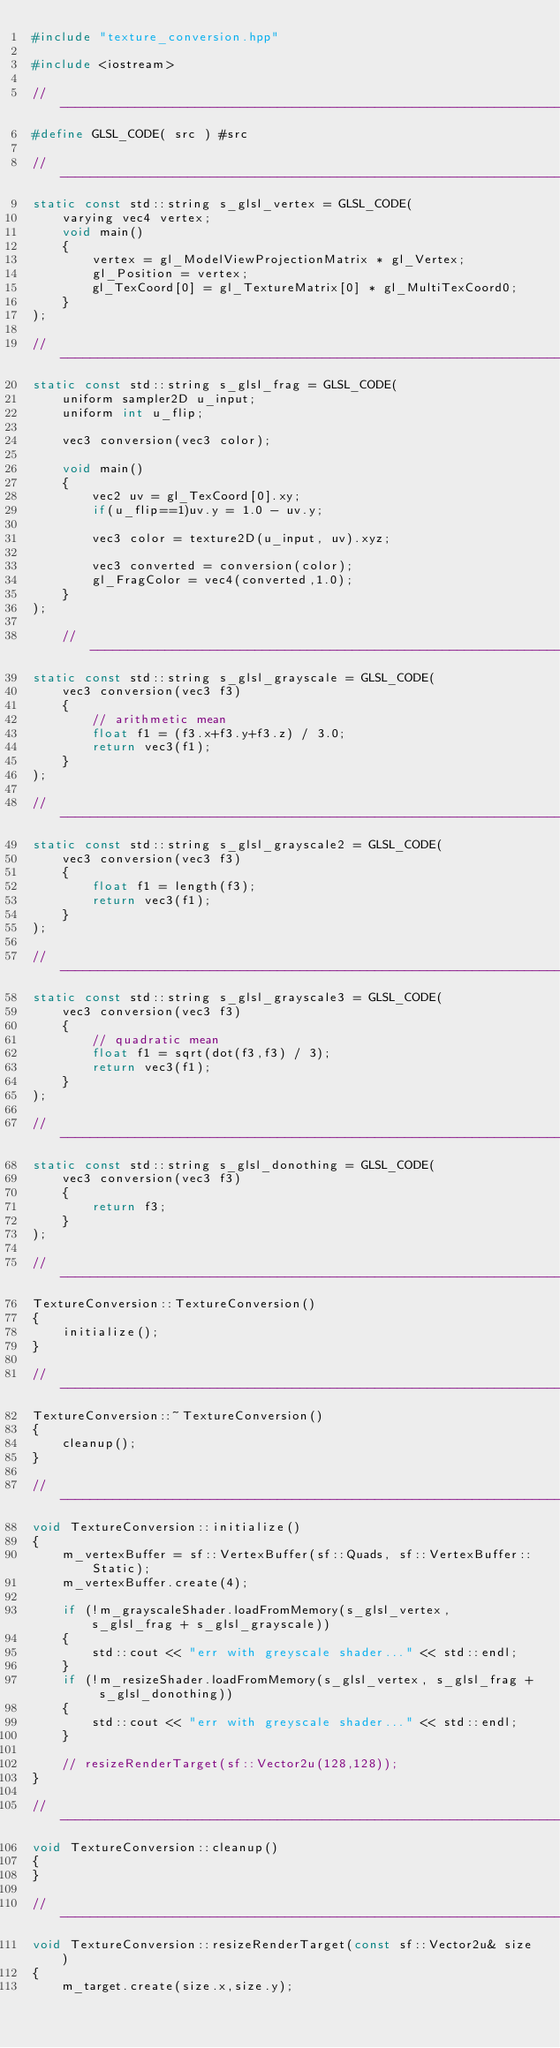Convert code to text. <code><loc_0><loc_0><loc_500><loc_500><_C++_>#include "texture_conversion.hpp"

#include <iostream>

// --------------------------------------------------------------------------
#define GLSL_CODE( src ) #src

// --------------------------------------------------------------------------
static const std::string s_glsl_vertex = GLSL_CODE(
    varying vec4 vertex;
    void main()
    {
        vertex = gl_ModelViewProjectionMatrix * gl_Vertex;
        gl_Position = vertex;
        gl_TexCoord[0] = gl_TextureMatrix[0] * gl_MultiTexCoord0;
    }
);

// --------------------------------------------------------------------------
static const std::string s_glsl_frag = GLSL_CODE(
    uniform sampler2D u_input;
    uniform int u_flip;

    vec3 conversion(vec3 color);

    void main()
    {
        vec2 uv = gl_TexCoord[0].xy;
        if(u_flip==1)uv.y = 1.0 - uv.y;

        vec3 color = texture2D(u_input, uv).xyz;

        vec3 converted = conversion(color);
        gl_FragColor = vec4(converted,1.0);
    }
);

    // --------------------------------------------------------------------------
static const std::string s_glsl_grayscale = GLSL_CODE(
    vec3 conversion(vec3 f3)
    {
        // arithmetic mean
        float f1 = (f3.x+f3.y+f3.z) / 3.0;
        return vec3(f1);
    }
);

// --------------------------------------------------------------------------
static const std::string s_glsl_grayscale2 = GLSL_CODE(
    vec3 conversion(vec3 f3)
    {
        float f1 = length(f3);
        return vec3(f1);
    }
);

// --------------------------------------------------------------------------
static const std::string s_glsl_grayscale3 = GLSL_CODE(
    vec3 conversion(vec3 f3)
    {
        // quadratic mean
        float f1 = sqrt(dot(f3,f3) / 3);
        return vec3(f1);
    }
);

// --------------------------------------------------------------------------
static const std::string s_glsl_donothing = GLSL_CODE(
    vec3 conversion(vec3 f3)
    {
        return f3;
    }
);

// --------------------------------------------------------------------------
TextureConversion::TextureConversion()
{
    initialize();
}

// --------------------------------------------------------------------------
TextureConversion::~TextureConversion()
{
    cleanup();
}

// --------------------------------------------------------------------------
void TextureConversion::initialize()
{
    m_vertexBuffer = sf::VertexBuffer(sf::Quads, sf::VertexBuffer::Static);
    m_vertexBuffer.create(4);

    if (!m_grayscaleShader.loadFromMemory(s_glsl_vertex, s_glsl_frag + s_glsl_grayscale))
    {
        std::cout << "err with greyscale shader..." << std::endl;
    }
    if (!m_resizeShader.loadFromMemory(s_glsl_vertex, s_glsl_frag + s_glsl_donothing))
    {
        std::cout << "err with greyscale shader..." << std::endl;
    }

    // resizeRenderTarget(sf::Vector2u(128,128));
}

// --------------------------------------------------------------------------
void TextureConversion::cleanup()
{
}

// --------------------------------------------------------------------------
void TextureConversion::resizeRenderTarget(const sf::Vector2u& size)
{
    m_target.create(size.x,size.y);
</code> 